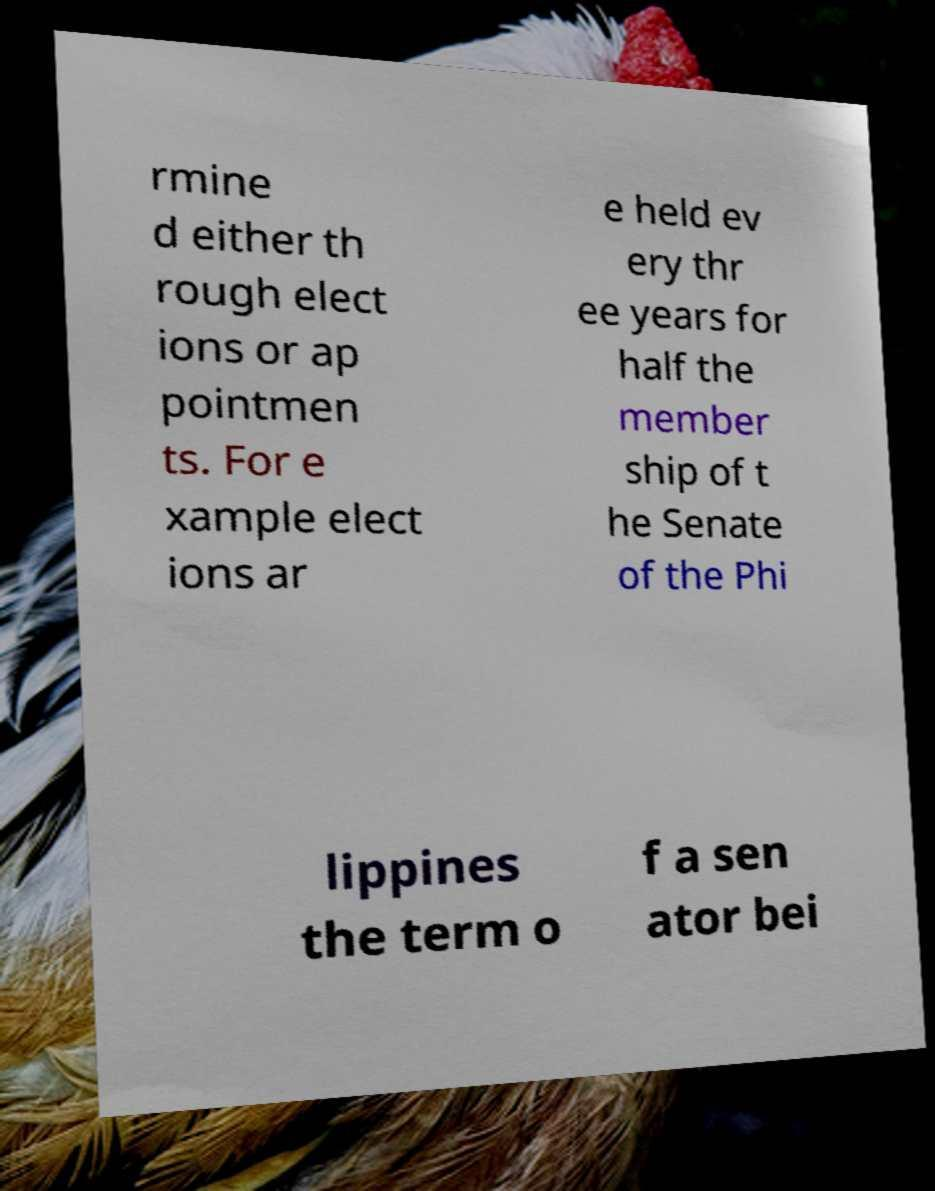Please read and relay the text visible in this image. What does it say? rmine d either th rough elect ions or ap pointmen ts. For e xample elect ions ar e held ev ery thr ee years for half the member ship of t he Senate of the Phi lippines the term o f a sen ator bei 